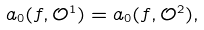Convert formula to latex. <formula><loc_0><loc_0><loc_500><loc_500>a _ { 0 } ( f , \mathcal { O } ^ { 1 } ) = a _ { 0 } ( f , \mathcal { O } ^ { 2 } ) ,</formula> 